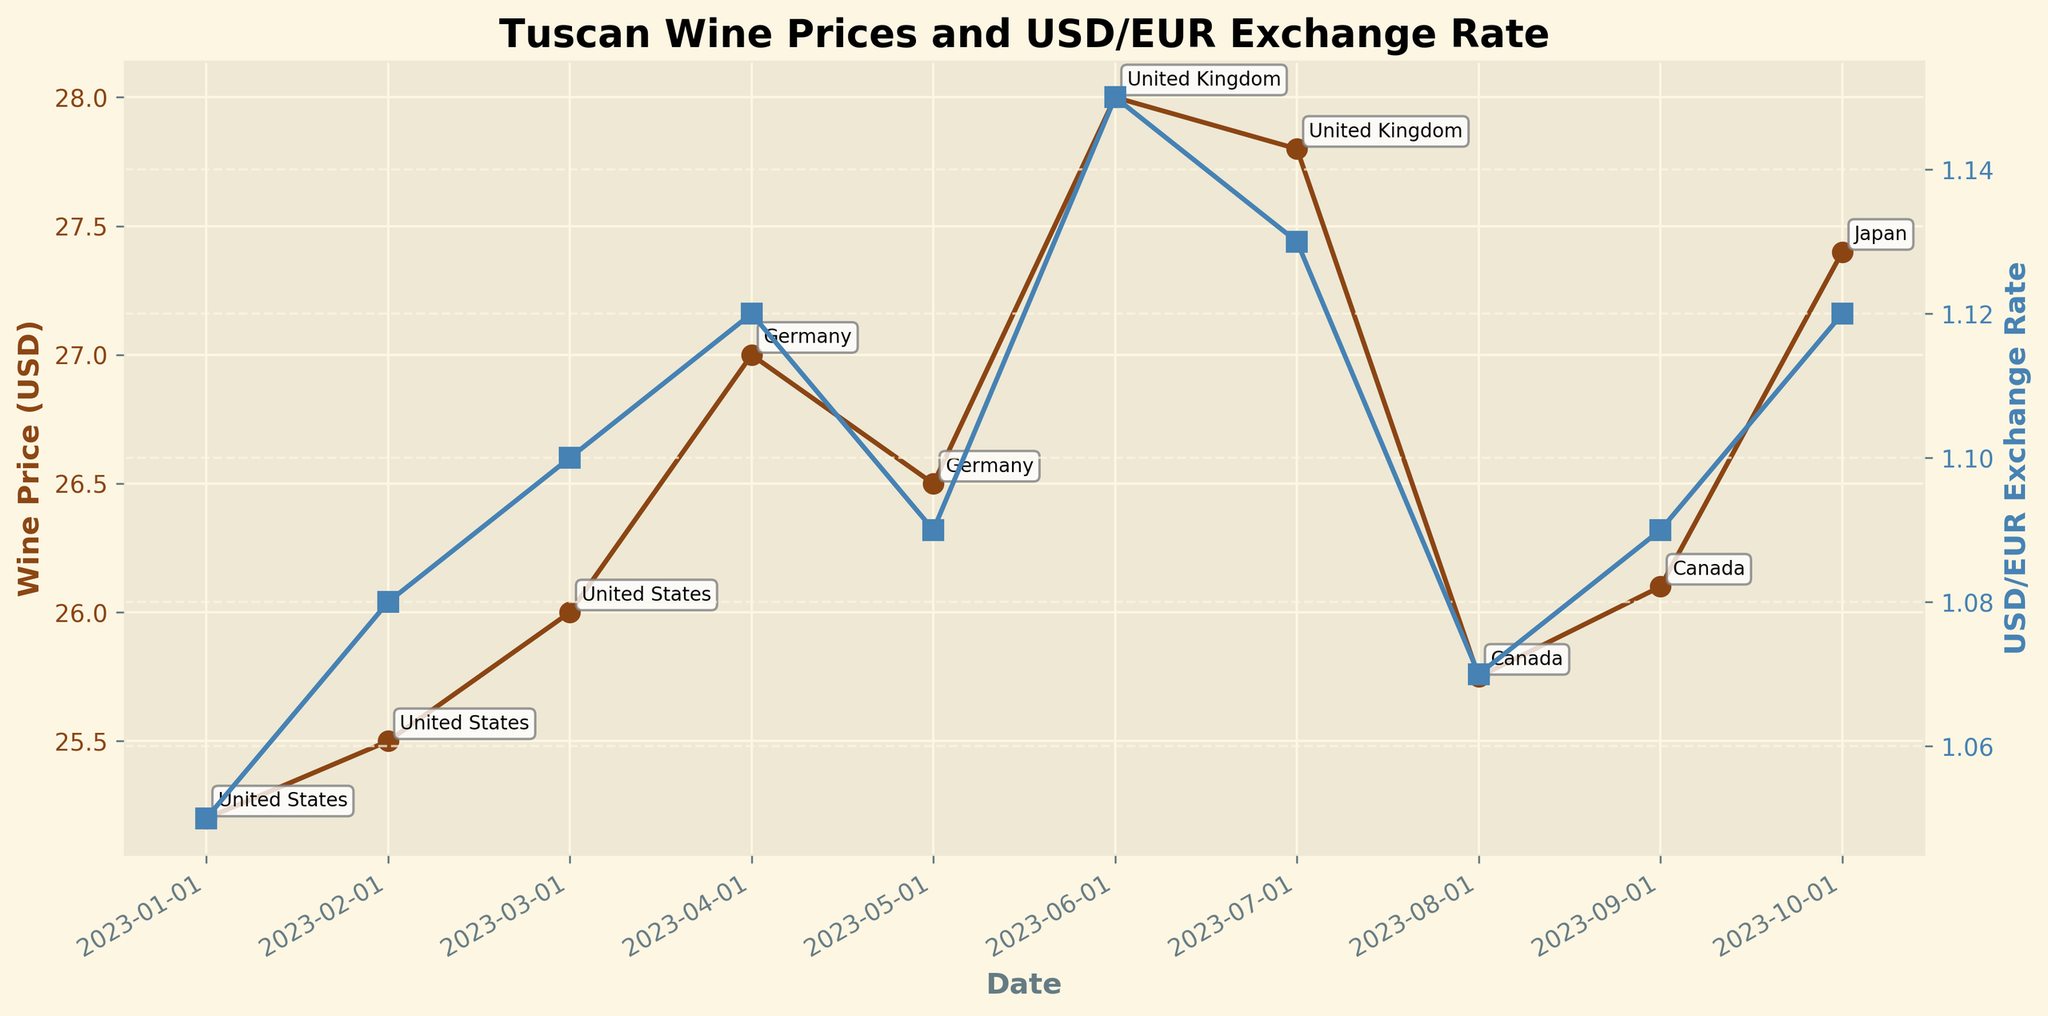What is the title of the figure? The title is located at the top center of the figure, which helps identify the main topic or purpose of the plot.
Answer: Tuscan Wine Prices and USD/EUR Exchange Rate How many countries are represented in the plot? By counting the annotations in the figure, we can identify the number of countries represented.
Answer: 5 What is the highest average wine price in USD shown on the plot? By inspecting the y-axis on the left (Wine Price in USD) and examining the highest data point on the wine price line, we identify the maximum value.
Answer: 28.00 USD Which month had the highest USD/EUR exchange rate? By looking at the y-axis on the right (USD/EUR Exchange Rate) and finding the peak value of the exchange rate line, we can determine the month corresponding to this peak.
Answer: June 2023 How does the average wine price in USD trend from January to March 2023? By observing the data points for the United States on the wine price line from January to March, one can identify if the prices are increasing, decreasing, or remaining stable.
Answer: Increasing Which country had the least fluctuation in wine prices in USD? By comparing the wine price data points of all countries and observing the range or variation in prices, the country with the smallest fluctuation can be identified.
Answer: United States What is the difference in average wine price (USD) between the United Kingdom in June and Germany in April? Calculate the wine prices for these two data points and compute the difference: 28.00 (UK in June) - 27.00 (Germany in April).
Answer: 1.00 USD Does the exchange rate appear to influence the average wine price (USD) in the United States? By comparing the trend of the exchange rate line with the wine price line for the United States, one can assess if there seems to be a correlation.
Answer: No clear influence How does the average wine price (EUR) compare between Germany and Japan? By examining the data points for Germany and Japan on the wine price line corresponding to EUR values, one can compare these prices directly.
Answer: Germany: 24.11 EUR, Japan: 24.46 EUR What visual elements help distinguish the wine price from the exchange rate in the plot? Identifying visual aids such as colors, markers, or line styles that differentiate the wine price line from the exchange rate line in the figure assists in interpretation.
Answer: Color and markers 